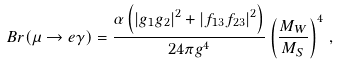Convert formula to latex. <formula><loc_0><loc_0><loc_500><loc_500>B r ( \mu \to e \gamma ) = \frac { \alpha \left ( \left | g _ { 1 } g _ { 2 } \right | ^ { 2 } + \left | f _ { 1 3 } f _ { 2 3 } \right | ^ { 2 } \right ) } { 2 4 \pi g ^ { 4 } } \left ( \frac { M _ { W } } { M _ { S } } \right ) ^ { 4 } \, ,</formula> 